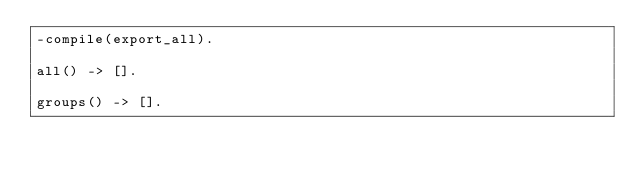Convert code to text. <code><loc_0><loc_0><loc_500><loc_500><_Erlang_>-compile(export_all).

all() -> [].

groups() -> [].
</code> 